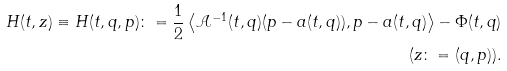<formula> <loc_0><loc_0><loc_500><loc_500>H ( t , z ) \equiv H ( t , q , p ) \colon = \frac { 1 } { 2 } \left \langle \mathcal { A } ^ { - 1 } ( t , q ) ( p - a ( t , q ) ) , p - a ( t , q ) \right \rangle - \Phi ( t , q ) \\ ( z \colon = ( q , p ) ) .</formula> 